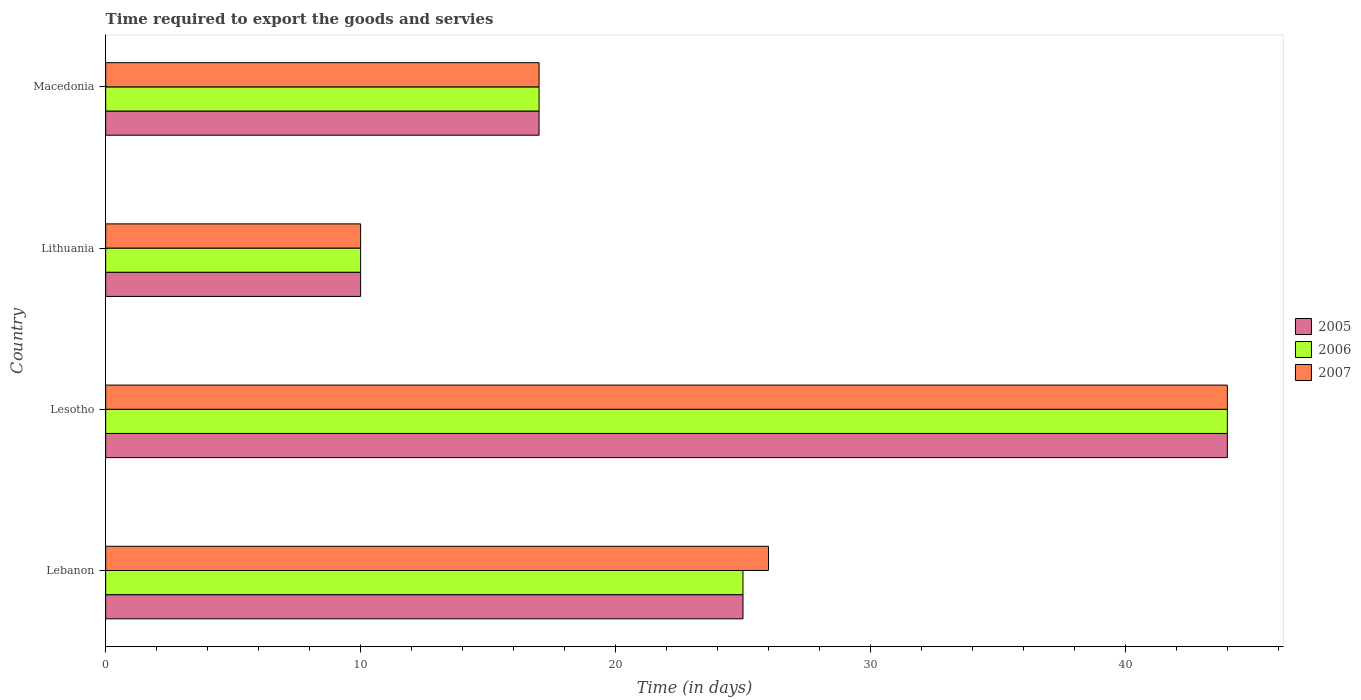How many different coloured bars are there?
Keep it short and to the point. 3. What is the label of the 2nd group of bars from the top?
Provide a short and direct response. Lithuania. In how many cases, is the number of bars for a given country not equal to the number of legend labels?
Ensure brevity in your answer.  0. Across all countries, what is the maximum number of days required to export the goods and services in 2006?
Offer a very short reply. 44. Across all countries, what is the minimum number of days required to export the goods and services in 2006?
Offer a terse response. 10. In which country was the number of days required to export the goods and services in 2006 maximum?
Ensure brevity in your answer.  Lesotho. In which country was the number of days required to export the goods and services in 2007 minimum?
Ensure brevity in your answer.  Lithuania. What is the total number of days required to export the goods and services in 2007 in the graph?
Offer a terse response. 97. What is the difference between the number of days required to export the goods and services in 2006 in Lebanon and that in Macedonia?
Your response must be concise. 8. What is the ratio of the number of days required to export the goods and services in 2005 in Lesotho to that in Macedonia?
Provide a succinct answer. 2.59. Is the number of days required to export the goods and services in 2006 in Lebanon less than that in Macedonia?
Your answer should be very brief. No. What is the difference between the highest and the second highest number of days required to export the goods and services in 2005?
Provide a succinct answer. 19. In how many countries, is the number of days required to export the goods and services in 2007 greater than the average number of days required to export the goods and services in 2007 taken over all countries?
Offer a terse response. 2. Is the sum of the number of days required to export the goods and services in 2007 in Lesotho and Lithuania greater than the maximum number of days required to export the goods and services in 2005 across all countries?
Your response must be concise. Yes. Is it the case that in every country, the sum of the number of days required to export the goods and services in 2005 and number of days required to export the goods and services in 2007 is greater than the number of days required to export the goods and services in 2006?
Your response must be concise. Yes. How many bars are there?
Offer a terse response. 12. Are all the bars in the graph horizontal?
Your response must be concise. Yes. Are the values on the major ticks of X-axis written in scientific E-notation?
Make the answer very short. No. Does the graph contain grids?
Your answer should be compact. No. How many legend labels are there?
Make the answer very short. 3. What is the title of the graph?
Give a very brief answer. Time required to export the goods and servies. Does "1979" appear as one of the legend labels in the graph?
Make the answer very short. No. What is the label or title of the X-axis?
Offer a terse response. Time (in days). What is the label or title of the Y-axis?
Your response must be concise. Country. What is the Time (in days) in 2005 in Lebanon?
Ensure brevity in your answer.  25. What is the Time (in days) of 2006 in Lithuania?
Provide a succinct answer. 10. What is the Time (in days) of 2007 in Lithuania?
Your response must be concise. 10. What is the Time (in days) of 2007 in Macedonia?
Offer a terse response. 17. Across all countries, what is the maximum Time (in days) of 2005?
Make the answer very short. 44. Across all countries, what is the minimum Time (in days) in 2007?
Give a very brief answer. 10. What is the total Time (in days) in 2005 in the graph?
Offer a very short reply. 96. What is the total Time (in days) in 2006 in the graph?
Give a very brief answer. 96. What is the total Time (in days) in 2007 in the graph?
Offer a very short reply. 97. What is the difference between the Time (in days) of 2006 in Lebanon and that in Lesotho?
Your response must be concise. -19. What is the difference between the Time (in days) in 2007 in Lebanon and that in Lesotho?
Ensure brevity in your answer.  -18. What is the difference between the Time (in days) of 2005 in Lebanon and that in Lithuania?
Ensure brevity in your answer.  15. What is the difference between the Time (in days) of 2006 in Lebanon and that in Lithuania?
Make the answer very short. 15. What is the difference between the Time (in days) in 2007 in Lebanon and that in Lithuania?
Your response must be concise. 16. What is the difference between the Time (in days) in 2005 in Lebanon and that in Macedonia?
Offer a terse response. 8. What is the difference between the Time (in days) of 2007 in Lebanon and that in Macedonia?
Provide a succinct answer. 9. What is the difference between the Time (in days) of 2005 in Lesotho and that in Lithuania?
Ensure brevity in your answer.  34. What is the difference between the Time (in days) in 2006 in Lesotho and that in Lithuania?
Ensure brevity in your answer.  34. What is the difference between the Time (in days) in 2007 in Lesotho and that in Macedonia?
Make the answer very short. 27. What is the difference between the Time (in days) of 2005 in Lithuania and that in Macedonia?
Provide a succinct answer. -7. What is the difference between the Time (in days) of 2006 in Lithuania and that in Macedonia?
Provide a short and direct response. -7. What is the difference between the Time (in days) of 2005 in Lebanon and the Time (in days) of 2006 in Lesotho?
Keep it short and to the point. -19. What is the difference between the Time (in days) of 2005 in Lebanon and the Time (in days) of 2007 in Lesotho?
Provide a succinct answer. -19. What is the difference between the Time (in days) of 2005 in Lebanon and the Time (in days) of 2006 in Lithuania?
Offer a very short reply. 15. What is the difference between the Time (in days) in 2005 in Lebanon and the Time (in days) in 2007 in Lithuania?
Your answer should be very brief. 15. What is the difference between the Time (in days) of 2006 in Lebanon and the Time (in days) of 2007 in Lithuania?
Your response must be concise. 15. What is the difference between the Time (in days) of 2005 in Lebanon and the Time (in days) of 2006 in Macedonia?
Offer a terse response. 8. What is the difference between the Time (in days) in 2005 in Lebanon and the Time (in days) in 2007 in Macedonia?
Your answer should be compact. 8. What is the difference between the Time (in days) in 2006 in Lebanon and the Time (in days) in 2007 in Macedonia?
Ensure brevity in your answer.  8. What is the difference between the Time (in days) of 2005 in Lesotho and the Time (in days) of 2006 in Lithuania?
Provide a succinct answer. 34. What is the difference between the Time (in days) in 2005 in Lesotho and the Time (in days) in 2007 in Lithuania?
Your answer should be very brief. 34. What is the difference between the Time (in days) in 2005 in Lesotho and the Time (in days) in 2007 in Macedonia?
Offer a terse response. 27. What is the difference between the Time (in days) in 2006 in Lesotho and the Time (in days) in 2007 in Macedonia?
Ensure brevity in your answer.  27. What is the difference between the Time (in days) of 2005 in Lithuania and the Time (in days) of 2006 in Macedonia?
Your response must be concise. -7. What is the difference between the Time (in days) in 2006 in Lithuania and the Time (in days) in 2007 in Macedonia?
Make the answer very short. -7. What is the average Time (in days) of 2005 per country?
Give a very brief answer. 24. What is the average Time (in days) of 2007 per country?
Provide a succinct answer. 24.25. What is the difference between the Time (in days) in 2005 and Time (in days) in 2006 in Lebanon?
Your response must be concise. 0. What is the difference between the Time (in days) of 2005 and Time (in days) of 2006 in Lesotho?
Your answer should be very brief. 0. What is the difference between the Time (in days) of 2005 and Time (in days) of 2007 in Lesotho?
Offer a terse response. 0. What is the difference between the Time (in days) in 2005 and Time (in days) in 2007 in Lithuania?
Provide a succinct answer. 0. What is the difference between the Time (in days) in 2006 and Time (in days) in 2007 in Macedonia?
Give a very brief answer. 0. What is the ratio of the Time (in days) in 2005 in Lebanon to that in Lesotho?
Your answer should be very brief. 0.57. What is the ratio of the Time (in days) in 2006 in Lebanon to that in Lesotho?
Your answer should be very brief. 0.57. What is the ratio of the Time (in days) in 2007 in Lebanon to that in Lesotho?
Make the answer very short. 0.59. What is the ratio of the Time (in days) of 2005 in Lebanon to that in Lithuania?
Your answer should be very brief. 2.5. What is the ratio of the Time (in days) in 2007 in Lebanon to that in Lithuania?
Your answer should be compact. 2.6. What is the ratio of the Time (in days) of 2005 in Lebanon to that in Macedonia?
Give a very brief answer. 1.47. What is the ratio of the Time (in days) of 2006 in Lebanon to that in Macedonia?
Provide a short and direct response. 1.47. What is the ratio of the Time (in days) of 2007 in Lebanon to that in Macedonia?
Provide a succinct answer. 1.53. What is the ratio of the Time (in days) in 2006 in Lesotho to that in Lithuania?
Provide a short and direct response. 4.4. What is the ratio of the Time (in days) in 2007 in Lesotho to that in Lithuania?
Ensure brevity in your answer.  4.4. What is the ratio of the Time (in days) of 2005 in Lesotho to that in Macedonia?
Your response must be concise. 2.59. What is the ratio of the Time (in days) in 2006 in Lesotho to that in Macedonia?
Offer a terse response. 2.59. What is the ratio of the Time (in days) of 2007 in Lesotho to that in Macedonia?
Ensure brevity in your answer.  2.59. What is the ratio of the Time (in days) of 2005 in Lithuania to that in Macedonia?
Provide a short and direct response. 0.59. What is the ratio of the Time (in days) of 2006 in Lithuania to that in Macedonia?
Give a very brief answer. 0.59. What is the ratio of the Time (in days) of 2007 in Lithuania to that in Macedonia?
Keep it short and to the point. 0.59. What is the difference between the highest and the second highest Time (in days) of 2005?
Your answer should be compact. 19. What is the difference between the highest and the second highest Time (in days) in 2006?
Provide a succinct answer. 19. What is the difference between the highest and the lowest Time (in days) of 2005?
Your response must be concise. 34. 